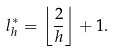Convert formula to latex. <formula><loc_0><loc_0><loc_500><loc_500>l ^ { * } _ { h } = \left \lfloor \frac { 2 } { h } \right \rfloor + 1 .</formula> 